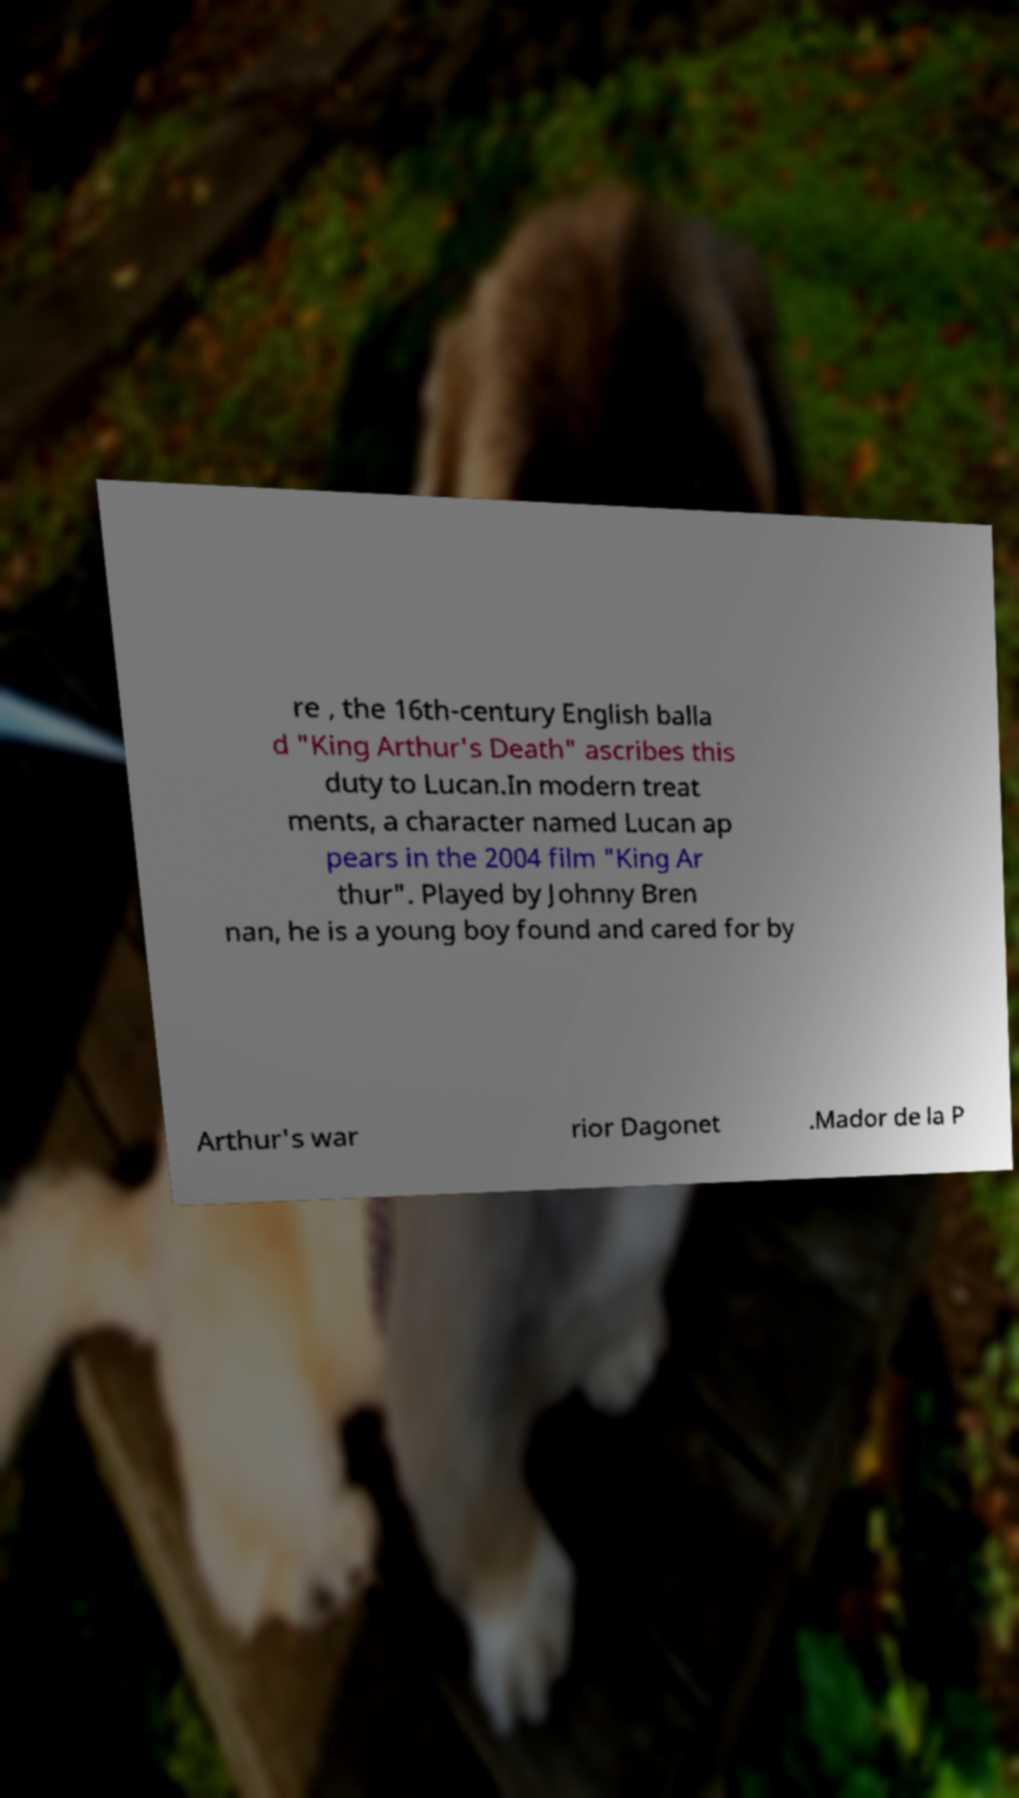Could you assist in decoding the text presented in this image and type it out clearly? re , the 16th-century English balla d "King Arthur's Death" ascribes this duty to Lucan.In modern treat ments, a character named Lucan ap pears in the 2004 film "King Ar thur". Played by Johnny Bren nan, he is a young boy found and cared for by Arthur's war rior Dagonet .Mador de la P 